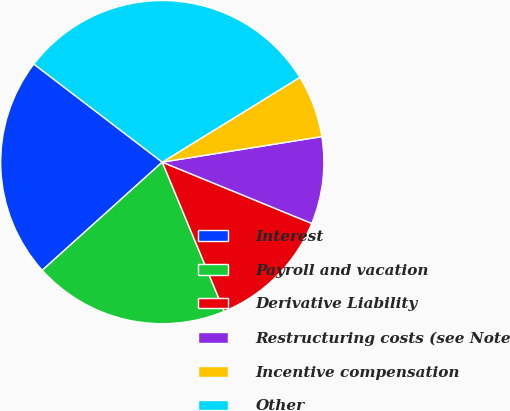Convert chart. <chart><loc_0><loc_0><loc_500><loc_500><pie_chart><fcel>Interest<fcel>Payroll and vacation<fcel>Derivative Liability<fcel>Restructuring costs (see Note<fcel>Incentive compensation<fcel>Other<nl><fcel>22.05%<fcel>19.59%<fcel>12.54%<fcel>8.72%<fcel>6.26%<fcel>30.83%<nl></chart> 